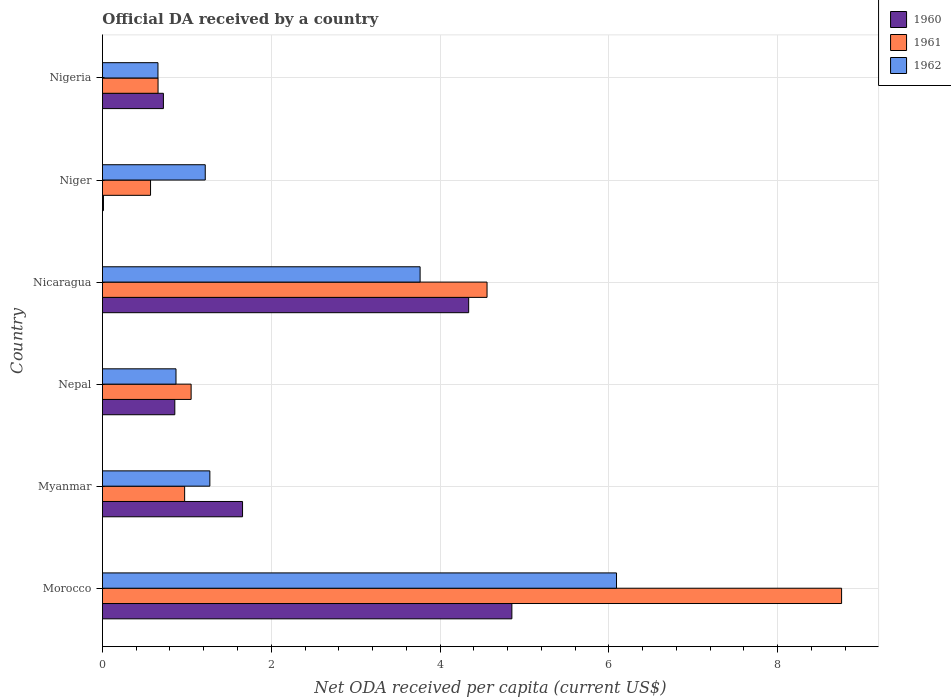How many different coloured bars are there?
Give a very brief answer. 3. How many bars are there on the 6th tick from the top?
Your answer should be very brief. 3. How many bars are there on the 2nd tick from the bottom?
Give a very brief answer. 3. What is the label of the 2nd group of bars from the top?
Ensure brevity in your answer.  Niger. What is the ODA received in in 1962 in Niger?
Give a very brief answer. 1.22. Across all countries, what is the maximum ODA received in in 1960?
Keep it short and to the point. 4.85. Across all countries, what is the minimum ODA received in in 1961?
Your response must be concise. 0.57. In which country was the ODA received in in 1962 maximum?
Ensure brevity in your answer.  Morocco. In which country was the ODA received in in 1961 minimum?
Your response must be concise. Niger. What is the total ODA received in in 1961 in the graph?
Offer a terse response. 16.57. What is the difference between the ODA received in in 1961 in Myanmar and that in Nigeria?
Make the answer very short. 0.31. What is the difference between the ODA received in in 1961 in Nepal and the ODA received in in 1960 in Niger?
Provide a succinct answer. 1.04. What is the average ODA received in in 1961 per country?
Ensure brevity in your answer.  2.76. What is the difference between the ODA received in in 1962 and ODA received in in 1960 in Myanmar?
Your answer should be very brief. -0.39. In how many countries, is the ODA received in in 1962 greater than 2.4 US$?
Provide a short and direct response. 2. What is the ratio of the ODA received in in 1960 in Myanmar to that in Nicaragua?
Your answer should be compact. 0.38. Is the difference between the ODA received in in 1962 in Myanmar and Niger greater than the difference between the ODA received in in 1960 in Myanmar and Niger?
Provide a short and direct response. No. What is the difference between the highest and the second highest ODA received in in 1961?
Give a very brief answer. 4.2. What is the difference between the highest and the lowest ODA received in in 1960?
Your response must be concise. 4.84. In how many countries, is the ODA received in in 1960 greater than the average ODA received in in 1960 taken over all countries?
Give a very brief answer. 2. What does the 2nd bar from the top in Niger represents?
Your answer should be very brief. 1961. What does the 1st bar from the bottom in Nicaragua represents?
Keep it short and to the point. 1960. Are all the bars in the graph horizontal?
Give a very brief answer. Yes. How many countries are there in the graph?
Your answer should be compact. 6. Does the graph contain any zero values?
Provide a succinct answer. No. Does the graph contain grids?
Your answer should be very brief. Yes. What is the title of the graph?
Offer a very short reply. Official DA received by a country. Does "1976" appear as one of the legend labels in the graph?
Provide a succinct answer. No. What is the label or title of the X-axis?
Provide a short and direct response. Net ODA received per capita (current US$). What is the label or title of the Y-axis?
Give a very brief answer. Country. What is the Net ODA received per capita (current US$) in 1960 in Morocco?
Offer a terse response. 4.85. What is the Net ODA received per capita (current US$) in 1961 in Morocco?
Your answer should be very brief. 8.76. What is the Net ODA received per capita (current US$) of 1962 in Morocco?
Your response must be concise. 6.09. What is the Net ODA received per capita (current US$) of 1960 in Myanmar?
Your response must be concise. 1.66. What is the Net ODA received per capita (current US$) in 1961 in Myanmar?
Provide a succinct answer. 0.97. What is the Net ODA received per capita (current US$) in 1962 in Myanmar?
Your answer should be very brief. 1.27. What is the Net ODA received per capita (current US$) in 1960 in Nepal?
Ensure brevity in your answer.  0.86. What is the Net ODA received per capita (current US$) in 1961 in Nepal?
Your answer should be very brief. 1.05. What is the Net ODA received per capita (current US$) in 1962 in Nepal?
Your answer should be compact. 0.87. What is the Net ODA received per capita (current US$) in 1960 in Nicaragua?
Your response must be concise. 4.34. What is the Net ODA received per capita (current US$) in 1961 in Nicaragua?
Offer a very short reply. 4.56. What is the Net ODA received per capita (current US$) of 1962 in Nicaragua?
Offer a very short reply. 3.76. What is the Net ODA received per capita (current US$) of 1960 in Niger?
Offer a very short reply. 0.01. What is the Net ODA received per capita (current US$) of 1961 in Niger?
Offer a very short reply. 0.57. What is the Net ODA received per capita (current US$) in 1962 in Niger?
Make the answer very short. 1.22. What is the Net ODA received per capita (current US$) in 1960 in Nigeria?
Your response must be concise. 0.72. What is the Net ODA received per capita (current US$) of 1961 in Nigeria?
Provide a short and direct response. 0.66. What is the Net ODA received per capita (current US$) of 1962 in Nigeria?
Provide a short and direct response. 0.66. Across all countries, what is the maximum Net ODA received per capita (current US$) in 1960?
Provide a succinct answer. 4.85. Across all countries, what is the maximum Net ODA received per capita (current US$) of 1961?
Your response must be concise. 8.76. Across all countries, what is the maximum Net ODA received per capita (current US$) of 1962?
Provide a short and direct response. 6.09. Across all countries, what is the minimum Net ODA received per capita (current US$) in 1960?
Your answer should be compact. 0.01. Across all countries, what is the minimum Net ODA received per capita (current US$) of 1961?
Provide a short and direct response. 0.57. Across all countries, what is the minimum Net ODA received per capita (current US$) in 1962?
Provide a succinct answer. 0.66. What is the total Net ODA received per capita (current US$) in 1960 in the graph?
Give a very brief answer. 12.44. What is the total Net ODA received per capita (current US$) in 1961 in the graph?
Provide a short and direct response. 16.57. What is the total Net ODA received per capita (current US$) of 1962 in the graph?
Make the answer very short. 13.87. What is the difference between the Net ODA received per capita (current US$) of 1960 in Morocco and that in Myanmar?
Make the answer very short. 3.19. What is the difference between the Net ODA received per capita (current US$) of 1961 in Morocco and that in Myanmar?
Offer a very short reply. 7.78. What is the difference between the Net ODA received per capita (current US$) in 1962 in Morocco and that in Myanmar?
Your answer should be very brief. 4.82. What is the difference between the Net ODA received per capita (current US$) in 1960 in Morocco and that in Nepal?
Your answer should be compact. 3.99. What is the difference between the Net ODA received per capita (current US$) of 1961 in Morocco and that in Nepal?
Ensure brevity in your answer.  7.71. What is the difference between the Net ODA received per capita (current US$) in 1962 in Morocco and that in Nepal?
Offer a terse response. 5.22. What is the difference between the Net ODA received per capita (current US$) of 1960 in Morocco and that in Nicaragua?
Your answer should be very brief. 0.51. What is the difference between the Net ODA received per capita (current US$) of 1961 in Morocco and that in Nicaragua?
Your response must be concise. 4.2. What is the difference between the Net ODA received per capita (current US$) in 1962 in Morocco and that in Nicaragua?
Ensure brevity in your answer.  2.33. What is the difference between the Net ODA received per capita (current US$) in 1960 in Morocco and that in Niger?
Your answer should be very brief. 4.84. What is the difference between the Net ODA received per capita (current US$) of 1961 in Morocco and that in Niger?
Offer a very short reply. 8.19. What is the difference between the Net ODA received per capita (current US$) in 1962 in Morocco and that in Niger?
Provide a succinct answer. 4.87. What is the difference between the Net ODA received per capita (current US$) in 1960 in Morocco and that in Nigeria?
Your answer should be compact. 4.13. What is the difference between the Net ODA received per capita (current US$) of 1961 in Morocco and that in Nigeria?
Your answer should be very brief. 8.1. What is the difference between the Net ODA received per capita (current US$) of 1962 in Morocco and that in Nigeria?
Offer a terse response. 5.43. What is the difference between the Net ODA received per capita (current US$) of 1960 in Myanmar and that in Nepal?
Your answer should be compact. 0.8. What is the difference between the Net ODA received per capita (current US$) in 1961 in Myanmar and that in Nepal?
Make the answer very short. -0.08. What is the difference between the Net ODA received per capita (current US$) of 1962 in Myanmar and that in Nepal?
Your response must be concise. 0.4. What is the difference between the Net ODA received per capita (current US$) of 1960 in Myanmar and that in Nicaragua?
Your response must be concise. -2.68. What is the difference between the Net ODA received per capita (current US$) of 1961 in Myanmar and that in Nicaragua?
Ensure brevity in your answer.  -3.58. What is the difference between the Net ODA received per capita (current US$) in 1962 in Myanmar and that in Nicaragua?
Give a very brief answer. -2.49. What is the difference between the Net ODA received per capita (current US$) in 1960 in Myanmar and that in Niger?
Offer a terse response. 1.65. What is the difference between the Net ODA received per capita (current US$) of 1961 in Myanmar and that in Niger?
Provide a succinct answer. 0.4. What is the difference between the Net ODA received per capita (current US$) in 1962 in Myanmar and that in Niger?
Ensure brevity in your answer.  0.05. What is the difference between the Net ODA received per capita (current US$) in 1960 in Myanmar and that in Nigeria?
Ensure brevity in your answer.  0.94. What is the difference between the Net ODA received per capita (current US$) in 1961 in Myanmar and that in Nigeria?
Give a very brief answer. 0.31. What is the difference between the Net ODA received per capita (current US$) of 1962 in Myanmar and that in Nigeria?
Provide a succinct answer. 0.61. What is the difference between the Net ODA received per capita (current US$) in 1960 in Nepal and that in Nicaragua?
Make the answer very short. -3.48. What is the difference between the Net ODA received per capita (current US$) of 1961 in Nepal and that in Nicaragua?
Provide a succinct answer. -3.51. What is the difference between the Net ODA received per capita (current US$) in 1962 in Nepal and that in Nicaragua?
Your answer should be compact. -2.89. What is the difference between the Net ODA received per capita (current US$) in 1960 in Nepal and that in Niger?
Offer a very short reply. 0.85. What is the difference between the Net ODA received per capita (current US$) in 1961 in Nepal and that in Niger?
Keep it short and to the point. 0.48. What is the difference between the Net ODA received per capita (current US$) in 1962 in Nepal and that in Niger?
Give a very brief answer. -0.35. What is the difference between the Net ODA received per capita (current US$) of 1960 in Nepal and that in Nigeria?
Keep it short and to the point. 0.14. What is the difference between the Net ODA received per capita (current US$) in 1961 in Nepal and that in Nigeria?
Keep it short and to the point. 0.39. What is the difference between the Net ODA received per capita (current US$) in 1962 in Nepal and that in Nigeria?
Provide a short and direct response. 0.21. What is the difference between the Net ODA received per capita (current US$) in 1960 in Nicaragua and that in Niger?
Provide a short and direct response. 4.33. What is the difference between the Net ODA received per capita (current US$) in 1961 in Nicaragua and that in Niger?
Make the answer very short. 3.99. What is the difference between the Net ODA received per capita (current US$) in 1962 in Nicaragua and that in Niger?
Give a very brief answer. 2.55. What is the difference between the Net ODA received per capita (current US$) of 1960 in Nicaragua and that in Nigeria?
Give a very brief answer. 3.62. What is the difference between the Net ODA received per capita (current US$) in 1961 in Nicaragua and that in Nigeria?
Your answer should be very brief. 3.9. What is the difference between the Net ODA received per capita (current US$) in 1962 in Nicaragua and that in Nigeria?
Keep it short and to the point. 3.11. What is the difference between the Net ODA received per capita (current US$) of 1960 in Niger and that in Nigeria?
Provide a short and direct response. -0.71. What is the difference between the Net ODA received per capita (current US$) in 1961 in Niger and that in Nigeria?
Keep it short and to the point. -0.09. What is the difference between the Net ODA received per capita (current US$) in 1962 in Niger and that in Nigeria?
Provide a short and direct response. 0.56. What is the difference between the Net ODA received per capita (current US$) in 1960 in Morocco and the Net ODA received per capita (current US$) in 1961 in Myanmar?
Offer a terse response. 3.88. What is the difference between the Net ODA received per capita (current US$) of 1960 in Morocco and the Net ODA received per capita (current US$) of 1962 in Myanmar?
Give a very brief answer. 3.58. What is the difference between the Net ODA received per capita (current US$) of 1961 in Morocco and the Net ODA received per capita (current US$) of 1962 in Myanmar?
Offer a terse response. 7.48. What is the difference between the Net ODA received per capita (current US$) in 1960 in Morocco and the Net ODA received per capita (current US$) in 1961 in Nepal?
Provide a short and direct response. 3.8. What is the difference between the Net ODA received per capita (current US$) in 1960 in Morocco and the Net ODA received per capita (current US$) in 1962 in Nepal?
Offer a terse response. 3.98. What is the difference between the Net ODA received per capita (current US$) in 1961 in Morocco and the Net ODA received per capita (current US$) in 1962 in Nepal?
Your response must be concise. 7.89. What is the difference between the Net ODA received per capita (current US$) in 1960 in Morocco and the Net ODA received per capita (current US$) in 1961 in Nicaragua?
Make the answer very short. 0.29. What is the difference between the Net ODA received per capita (current US$) of 1960 in Morocco and the Net ODA received per capita (current US$) of 1962 in Nicaragua?
Keep it short and to the point. 1.09. What is the difference between the Net ODA received per capita (current US$) of 1961 in Morocco and the Net ODA received per capita (current US$) of 1962 in Nicaragua?
Provide a short and direct response. 4.99. What is the difference between the Net ODA received per capita (current US$) in 1960 in Morocco and the Net ODA received per capita (current US$) in 1961 in Niger?
Offer a terse response. 4.28. What is the difference between the Net ODA received per capita (current US$) in 1960 in Morocco and the Net ODA received per capita (current US$) in 1962 in Niger?
Offer a very short reply. 3.63. What is the difference between the Net ODA received per capita (current US$) in 1961 in Morocco and the Net ODA received per capita (current US$) in 1962 in Niger?
Provide a short and direct response. 7.54. What is the difference between the Net ODA received per capita (current US$) of 1960 in Morocco and the Net ODA received per capita (current US$) of 1961 in Nigeria?
Your response must be concise. 4.19. What is the difference between the Net ODA received per capita (current US$) of 1960 in Morocco and the Net ODA received per capita (current US$) of 1962 in Nigeria?
Ensure brevity in your answer.  4.19. What is the difference between the Net ODA received per capita (current US$) in 1961 in Morocco and the Net ODA received per capita (current US$) in 1962 in Nigeria?
Provide a short and direct response. 8.1. What is the difference between the Net ODA received per capita (current US$) in 1960 in Myanmar and the Net ODA received per capita (current US$) in 1961 in Nepal?
Your answer should be very brief. 0.61. What is the difference between the Net ODA received per capita (current US$) of 1960 in Myanmar and the Net ODA received per capita (current US$) of 1962 in Nepal?
Provide a short and direct response. 0.79. What is the difference between the Net ODA received per capita (current US$) of 1961 in Myanmar and the Net ODA received per capita (current US$) of 1962 in Nepal?
Your answer should be compact. 0.1. What is the difference between the Net ODA received per capita (current US$) of 1960 in Myanmar and the Net ODA received per capita (current US$) of 1961 in Nicaragua?
Keep it short and to the point. -2.9. What is the difference between the Net ODA received per capita (current US$) of 1960 in Myanmar and the Net ODA received per capita (current US$) of 1962 in Nicaragua?
Offer a very short reply. -2.1. What is the difference between the Net ODA received per capita (current US$) of 1961 in Myanmar and the Net ODA received per capita (current US$) of 1962 in Nicaragua?
Make the answer very short. -2.79. What is the difference between the Net ODA received per capita (current US$) in 1960 in Myanmar and the Net ODA received per capita (current US$) in 1961 in Niger?
Give a very brief answer. 1.09. What is the difference between the Net ODA received per capita (current US$) in 1960 in Myanmar and the Net ODA received per capita (current US$) in 1962 in Niger?
Provide a short and direct response. 0.44. What is the difference between the Net ODA received per capita (current US$) in 1961 in Myanmar and the Net ODA received per capita (current US$) in 1962 in Niger?
Your answer should be very brief. -0.24. What is the difference between the Net ODA received per capita (current US$) in 1960 in Myanmar and the Net ODA received per capita (current US$) in 1961 in Nigeria?
Keep it short and to the point. 1. What is the difference between the Net ODA received per capita (current US$) of 1961 in Myanmar and the Net ODA received per capita (current US$) of 1962 in Nigeria?
Offer a very short reply. 0.32. What is the difference between the Net ODA received per capita (current US$) of 1960 in Nepal and the Net ODA received per capita (current US$) of 1961 in Nicaragua?
Make the answer very short. -3.7. What is the difference between the Net ODA received per capita (current US$) in 1960 in Nepal and the Net ODA received per capita (current US$) in 1962 in Nicaragua?
Offer a very short reply. -2.91. What is the difference between the Net ODA received per capita (current US$) of 1961 in Nepal and the Net ODA received per capita (current US$) of 1962 in Nicaragua?
Provide a succinct answer. -2.71. What is the difference between the Net ODA received per capita (current US$) in 1960 in Nepal and the Net ODA received per capita (current US$) in 1961 in Niger?
Your answer should be very brief. 0.29. What is the difference between the Net ODA received per capita (current US$) in 1960 in Nepal and the Net ODA received per capita (current US$) in 1962 in Niger?
Offer a terse response. -0.36. What is the difference between the Net ODA received per capita (current US$) of 1961 in Nepal and the Net ODA received per capita (current US$) of 1962 in Niger?
Keep it short and to the point. -0.17. What is the difference between the Net ODA received per capita (current US$) of 1960 in Nepal and the Net ODA received per capita (current US$) of 1961 in Nigeria?
Your answer should be very brief. 0.2. What is the difference between the Net ODA received per capita (current US$) of 1960 in Nepal and the Net ODA received per capita (current US$) of 1962 in Nigeria?
Your answer should be compact. 0.2. What is the difference between the Net ODA received per capita (current US$) in 1961 in Nepal and the Net ODA received per capita (current US$) in 1962 in Nigeria?
Your answer should be compact. 0.39. What is the difference between the Net ODA received per capita (current US$) in 1960 in Nicaragua and the Net ODA received per capita (current US$) in 1961 in Niger?
Give a very brief answer. 3.77. What is the difference between the Net ODA received per capita (current US$) in 1960 in Nicaragua and the Net ODA received per capita (current US$) in 1962 in Niger?
Give a very brief answer. 3.12. What is the difference between the Net ODA received per capita (current US$) of 1961 in Nicaragua and the Net ODA received per capita (current US$) of 1962 in Niger?
Make the answer very short. 3.34. What is the difference between the Net ODA received per capita (current US$) in 1960 in Nicaragua and the Net ODA received per capita (current US$) in 1961 in Nigeria?
Offer a very short reply. 3.68. What is the difference between the Net ODA received per capita (current US$) in 1960 in Nicaragua and the Net ODA received per capita (current US$) in 1962 in Nigeria?
Provide a short and direct response. 3.68. What is the difference between the Net ODA received per capita (current US$) in 1961 in Nicaragua and the Net ODA received per capita (current US$) in 1962 in Nigeria?
Offer a terse response. 3.9. What is the difference between the Net ODA received per capita (current US$) in 1960 in Niger and the Net ODA received per capita (current US$) in 1961 in Nigeria?
Your answer should be compact. -0.65. What is the difference between the Net ODA received per capita (current US$) of 1960 in Niger and the Net ODA received per capita (current US$) of 1962 in Nigeria?
Your answer should be very brief. -0.65. What is the difference between the Net ODA received per capita (current US$) of 1961 in Niger and the Net ODA received per capita (current US$) of 1962 in Nigeria?
Provide a short and direct response. -0.09. What is the average Net ODA received per capita (current US$) of 1960 per country?
Your answer should be very brief. 2.07. What is the average Net ODA received per capita (current US$) in 1961 per country?
Ensure brevity in your answer.  2.76. What is the average Net ODA received per capita (current US$) in 1962 per country?
Offer a very short reply. 2.31. What is the difference between the Net ODA received per capita (current US$) in 1960 and Net ODA received per capita (current US$) in 1961 in Morocco?
Your answer should be very brief. -3.91. What is the difference between the Net ODA received per capita (current US$) in 1960 and Net ODA received per capita (current US$) in 1962 in Morocco?
Provide a succinct answer. -1.24. What is the difference between the Net ODA received per capita (current US$) of 1961 and Net ODA received per capita (current US$) of 1962 in Morocco?
Offer a very short reply. 2.67. What is the difference between the Net ODA received per capita (current US$) in 1960 and Net ODA received per capita (current US$) in 1961 in Myanmar?
Provide a short and direct response. 0.69. What is the difference between the Net ODA received per capita (current US$) in 1960 and Net ODA received per capita (current US$) in 1962 in Myanmar?
Offer a terse response. 0.39. What is the difference between the Net ODA received per capita (current US$) of 1961 and Net ODA received per capita (current US$) of 1962 in Myanmar?
Offer a very short reply. -0.3. What is the difference between the Net ODA received per capita (current US$) in 1960 and Net ODA received per capita (current US$) in 1961 in Nepal?
Provide a succinct answer. -0.19. What is the difference between the Net ODA received per capita (current US$) in 1960 and Net ODA received per capita (current US$) in 1962 in Nepal?
Provide a succinct answer. -0.01. What is the difference between the Net ODA received per capita (current US$) in 1961 and Net ODA received per capita (current US$) in 1962 in Nepal?
Your response must be concise. 0.18. What is the difference between the Net ODA received per capita (current US$) in 1960 and Net ODA received per capita (current US$) in 1961 in Nicaragua?
Offer a terse response. -0.22. What is the difference between the Net ODA received per capita (current US$) of 1960 and Net ODA received per capita (current US$) of 1962 in Nicaragua?
Offer a terse response. 0.58. What is the difference between the Net ODA received per capita (current US$) in 1961 and Net ODA received per capita (current US$) in 1962 in Nicaragua?
Provide a short and direct response. 0.79. What is the difference between the Net ODA received per capita (current US$) of 1960 and Net ODA received per capita (current US$) of 1961 in Niger?
Offer a terse response. -0.56. What is the difference between the Net ODA received per capita (current US$) in 1960 and Net ODA received per capita (current US$) in 1962 in Niger?
Offer a terse response. -1.21. What is the difference between the Net ODA received per capita (current US$) of 1961 and Net ODA received per capita (current US$) of 1962 in Niger?
Give a very brief answer. -0.65. What is the difference between the Net ODA received per capita (current US$) in 1960 and Net ODA received per capita (current US$) in 1961 in Nigeria?
Provide a short and direct response. 0.06. What is the difference between the Net ODA received per capita (current US$) of 1960 and Net ODA received per capita (current US$) of 1962 in Nigeria?
Your response must be concise. 0.06. What is the difference between the Net ODA received per capita (current US$) in 1961 and Net ODA received per capita (current US$) in 1962 in Nigeria?
Ensure brevity in your answer.  0. What is the ratio of the Net ODA received per capita (current US$) in 1960 in Morocco to that in Myanmar?
Provide a short and direct response. 2.92. What is the ratio of the Net ODA received per capita (current US$) of 1961 in Morocco to that in Myanmar?
Provide a short and direct response. 9. What is the ratio of the Net ODA received per capita (current US$) in 1962 in Morocco to that in Myanmar?
Your answer should be very brief. 4.79. What is the ratio of the Net ODA received per capita (current US$) of 1960 in Morocco to that in Nepal?
Offer a very short reply. 5.66. What is the ratio of the Net ODA received per capita (current US$) of 1961 in Morocco to that in Nepal?
Offer a terse response. 8.34. What is the ratio of the Net ODA received per capita (current US$) of 1962 in Morocco to that in Nepal?
Provide a short and direct response. 6.99. What is the ratio of the Net ODA received per capita (current US$) of 1960 in Morocco to that in Nicaragua?
Keep it short and to the point. 1.12. What is the ratio of the Net ODA received per capita (current US$) in 1961 in Morocco to that in Nicaragua?
Make the answer very short. 1.92. What is the ratio of the Net ODA received per capita (current US$) of 1962 in Morocco to that in Nicaragua?
Your response must be concise. 1.62. What is the ratio of the Net ODA received per capita (current US$) in 1960 in Morocco to that in Niger?
Keep it short and to the point. 411.71. What is the ratio of the Net ODA received per capita (current US$) of 1961 in Morocco to that in Niger?
Offer a very short reply. 15.37. What is the ratio of the Net ODA received per capita (current US$) in 1962 in Morocco to that in Niger?
Offer a terse response. 5. What is the ratio of the Net ODA received per capita (current US$) in 1960 in Morocco to that in Nigeria?
Offer a terse response. 6.72. What is the ratio of the Net ODA received per capita (current US$) in 1961 in Morocco to that in Nigeria?
Make the answer very short. 13.3. What is the ratio of the Net ODA received per capita (current US$) in 1962 in Morocco to that in Nigeria?
Make the answer very short. 9.26. What is the ratio of the Net ODA received per capita (current US$) of 1960 in Myanmar to that in Nepal?
Your response must be concise. 1.94. What is the ratio of the Net ODA received per capita (current US$) of 1961 in Myanmar to that in Nepal?
Keep it short and to the point. 0.93. What is the ratio of the Net ODA received per capita (current US$) of 1962 in Myanmar to that in Nepal?
Your answer should be very brief. 1.46. What is the ratio of the Net ODA received per capita (current US$) in 1960 in Myanmar to that in Nicaragua?
Offer a terse response. 0.38. What is the ratio of the Net ODA received per capita (current US$) of 1961 in Myanmar to that in Nicaragua?
Give a very brief answer. 0.21. What is the ratio of the Net ODA received per capita (current US$) of 1962 in Myanmar to that in Nicaragua?
Your answer should be very brief. 0.34. What is the ratio of the Net ODA received per capita (current US$) in 1960 in Myanmar to that in Niger?
Provide a succinct answer. 140.87. What is the ratio of the Net ODA received per capita (current US$) in 1961 in Myanmar to that in Niger?
Offer a very short reply. 1.71. What is the ratio of the Net ODA received per capita (current US$) in 1962 in Myanmar to that in Niger?
Keep it short and to the point. 1.04. What is the ratio of the Net ODA received per capita (current US$) in 1960 in Myanmar to that in Nigeria?
Provide a succinct answer. 2.3. What is the ratio of the Net ODA received per capita (current US$) in 1961 in Myanmar to that in Nigeria?
Your answer should be very brief. 1.48. What is the ratio of the Net ODA received per capita (current US$) in 1962 in Myanmar to that in Nigeria?
Ensure brevity in your answer.  1.94. What is the ratio of the Net ODA received per capita (current US$) in 1960 in Nepal to that in Nicaragua?
Provide a short and direct response. 0.2. What is the ratio of the Net ODA received per capita (current US$) in 1961 in Nepal to that in Nicaragua?
Keep it short and to the point. 0.23. What is the ratio of the Net ODA received per capita (current US$) in 1962 in Nepal to that in Nicaragua?
Provide a succinct answer. 0.23. What is the ratio of the Net ODA received per capita (current US$) of 1960 in Nepal to that in Niger?
Your answer should be compact. 72.75. What is the ratio of the Net ODA received per capita (current US$) in 1961 in Nepal to that in Niger?
Your answer should be very brief. 1.84. What is the ratio of the Net ODA received per capita (current US$) in 1962 in Nepal to that in Niger?
Provide a succinct answer. 0.72. What is the ratio of the Net ODA received per capita (current US$) in 1960 in Nepal to that in Nigeria?
Keep it short and to the point. 1.19. What is the ratio of the Net ODA received per capita (current US$) in 1961 in Nepal to that in Nigeria?
Offer a very short reply. 1.59. What is the ratio of the Net ODA received per capita (current US$) in 1962 in Nepal to that in Nigeria?
Ensure brevity in your answer.  1.32. What is the ratio of the Net ODA received per capita (current US$) in 1960 in Nicaragua to that in Niger?
Your answer should be very brief. 368.28. What is the ratio of the Net ODA received per capita (current US$) of 1961 in Nicaragua to that in Niger?
Make the answer very short. 8. What is the ratio of the Net ODA received per capita (current US$) of 1962 in Nicaragua to that in Niger?
Give a very brief answer. 3.09. What is the ratio of the Net ODA received per capita (current US$) in 1960 in Nicaragua to that in Nigeria?
Make the answer very short. 6.01. What is the ratio of the Net ODA received per capita (current US$) in 1961 in Nicaragua to that in Nigeria?
Make the answer very short. 6.92. What is the ratio of the Net ODA received per capita (current US$) in 1962 in Nicaragua to that in Nigeria?
Keep it short and to the point. 5.72. What is the ratio of the Net ODA received per capita (current US$) in 1960 in Niger to that in Nigeria?
Keep it short and to the point. 0.02. What is the ratio of the Net ODA received per capita (current US$) in 1961 in Niger to that in Nigeria?
Offer a terse response. 0.86. What is the ratio of the Net ODA received per capita (current US$) in 1962 in Niger to that in Nigeria?
Give a very brief answer. 1.85. What is the difference between the highest and the second highest Net ODA received per capita (current US$) of 1960?
Provide a succinct answer. 0.51. What is the difference between the highest and the second highest Net ODA received per capita (current US$) of 1961?
Keep it short and to the point. 4.2. What is the difference between the highest and the second highest Net ODA received per capita (current US$) in 1962?
Ensure brevity in your answer.  2.33. What is the difference between the highest and the lowest Net ODA received per capita (current US$) of 1960?
Provide a short and direct response. 4.84. What is the difference between the highest and the lowest Net ODA received per capita (current US$) in 1961?
Your response must be concise. 8.19. What is the difference between the highest and the lowest Net ODA received per capita (current US$) in 1962?
Offer a very short reply. 5.43. 